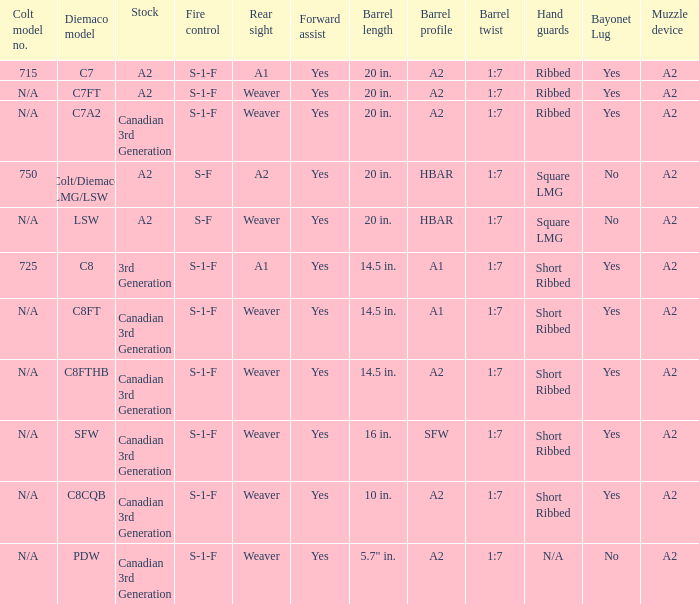Which Hand guards has a Barrel profile of a2 and a Rear sight of weaver? Ribbed, Ribbed, Short Ribbed, Short Ribbed, N/A. 